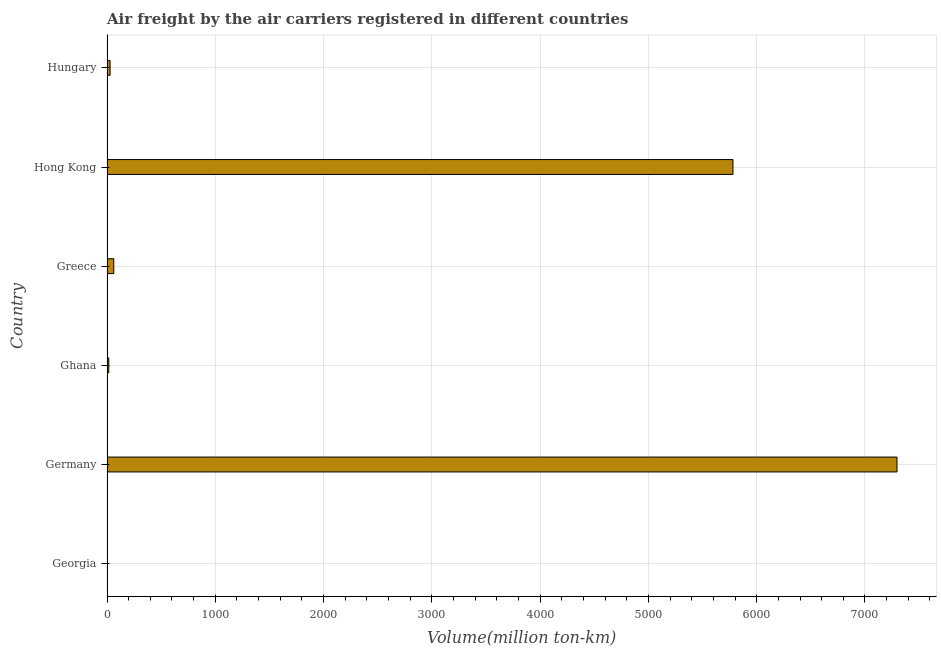Does the graph contain any zero values?
Give a very brief answer. No. What is the title of the graph?
Your answer should be very brief. Air freight by the air carriers registered in different countries. What is the label or title of the X-axis?
Your answer should be very brief. Volume(million ton-km). What is the air freight in Ghana?
Offer a very short reply. 16.63. Across all countries, what is the maximum air freight?
Provide a succinct answer. 7295.67. Across all countries, what is the minimum air freight?
Give a very brief answer. 4.49. In which country was the air freight minimum?
Your response must be concise. Georgia. What is the sum of the air freight?
Your answer should be compact. 1.32e+04. What is the difference between the air freight in Georgia and Ghana?
Give a very brief answer. -12.14. What is the average air freight per country?
Make the answer very short. 2198.11. What is the median air freight?
Provide a short and direct response. 45.56. What is the ratio of the air freight in Germany to that in Greece?
Your answer should be very brief. 116.27. What is the difference between the highest and the second highest air freight?
Your answer should be compact. 1514.92. Is the sum of the air freight in Germany and Greece greater than the maximum air freight across all countries?
Your answer should be very brief. Yes. What is the difference between the highest and the lowest air freight?
Provide a short and direct response. 7291.18. How many countries are there in the graph?
Provide a short and direct response. 6. What is the difference between two consecutive major ticks on the X-axis?
Your answer should be compact. 1000. What is the Volume(million ton-km) in Georgia?
Make the answer very short. 4.49. What is the Volume(million ton-km) in Germany?
Offer a terse response. 7295.67. What is the Volume(million ton-km) in Ghana?
Provide a succinct answer. 16.63. What is the Volume(million ton-km) of Greece?
Make the answer very short. 62.75. What is the Volume(million ton-km) of Hong Kong?
Your response must be concise. 5780.75. What is the Volume(million ton-km) of Hungary?
Offer a terse response. 28.37. What is the difference between the Volume(million ton-km) in Georgia and Germany?
Offer a terse response. -7291.18. What is the difference between the Volume(million ton-km) in Georgia and Ghana?
Provide a succinct answer. -12.14. What is the difference between the Volume(million ton-km) in Georgia and Greece?
Give a very brief answer. -58.26. What is the difference between the Volume(million ton-km) in Georgia and Hong Kong?
Offer a terse response. -5776.26. What is the difference between the Volume(million ton-km) in Georgia and Hungary?
Provide a succinct answer. -23.88. What is the difference between the Volume(million ton-km) in Germany and Ghana?
Your response must be concise. 7279.04. What is the difference between the Volume(million ton-km) in Germany and Greece?
Offer a very short reply. 7232.92. What is the difference between the Volume(million ton-km) in Germany and Hong Kong?
Your answer should be compact. 1514.92. What is the difference between the Volume(million ton-km) in Germany and Hungary?
Offer a terse response. 7267.3. What is the difference between the Volume(million ton-km) in Ghana and Greece?
Make the answer very short. -46.12. What is the difference between the Volume(million ton-km) in Ghana and Hong Kong?
Your response must be concise. -5764.12. What is the difference between the Volume(million ton-km) in Ghana and Hungary?
Provide a succinct answer. -11.74. What is the difference between the Volume(million ton-km) in Greece and Hong Kong?
Your answer should be very brief. -5718. What is the difference between the Volume(million ton-km) in Greece and Hungary?
Your answer should be compact. 34.38. What is the difference between the Volume(million ton-km) in Hong Kong and Hungary?
Ensure brevity in your answer.  5752.38. What is the ratio of the Volume(million ton-km) in Georgia to that in Ghana?
Give a very brief answer. 0.27. What is the ratio of the Volume(million ton-km) in Georgia to that in Greece?
Ensure brevity in your answer.  0.07. What is the ratio of the Volume(million ton-km) in Georgia to that in Hungary?
Your answer should be very brief. 0.16. What is the ratio of the Volume(million ton-km) in Germany to that in Ghana?
Make the answer very short. 438.7. What is the ratio of the Volume(million ton-km) in Germany to that in Greece?
Ensure brevity in your answer.  116.27. What is the ratio of the Volume(million ton-km) in Germany to that in Hong Kong?
Give a very brief answer. 1.26. What is the ratio of the Volume(million ton-km) in Germany to that in Hungary?
Your response must be concise. 257.16. What is the ratio of the Volume(million ton-km) in Ghana to that in Greece?
Offer a terse response. 0.27. What is the ratio of the Volume(million ton-km) in Ghana to that in Hong Kong?
Keep it short and to the point. 0. What is the ratio of the Volume(million ton-km) in Ghana to that in Hungary?
Your response must be concise. 0.59. What is the ratio of the Volume(million ton-km) in Greece to that in Hong Kong?
Ensure brevity in your answer.  0.01. What is the ratio of the Volume(million ton-km) in Greece to that in Hungary?
Ensure brevity in your answer.  2.21. What is the ratio of the Volume(million ton-km) in Hong Kong to that in Hungary?
Your answer should be very brief. 203.76. 